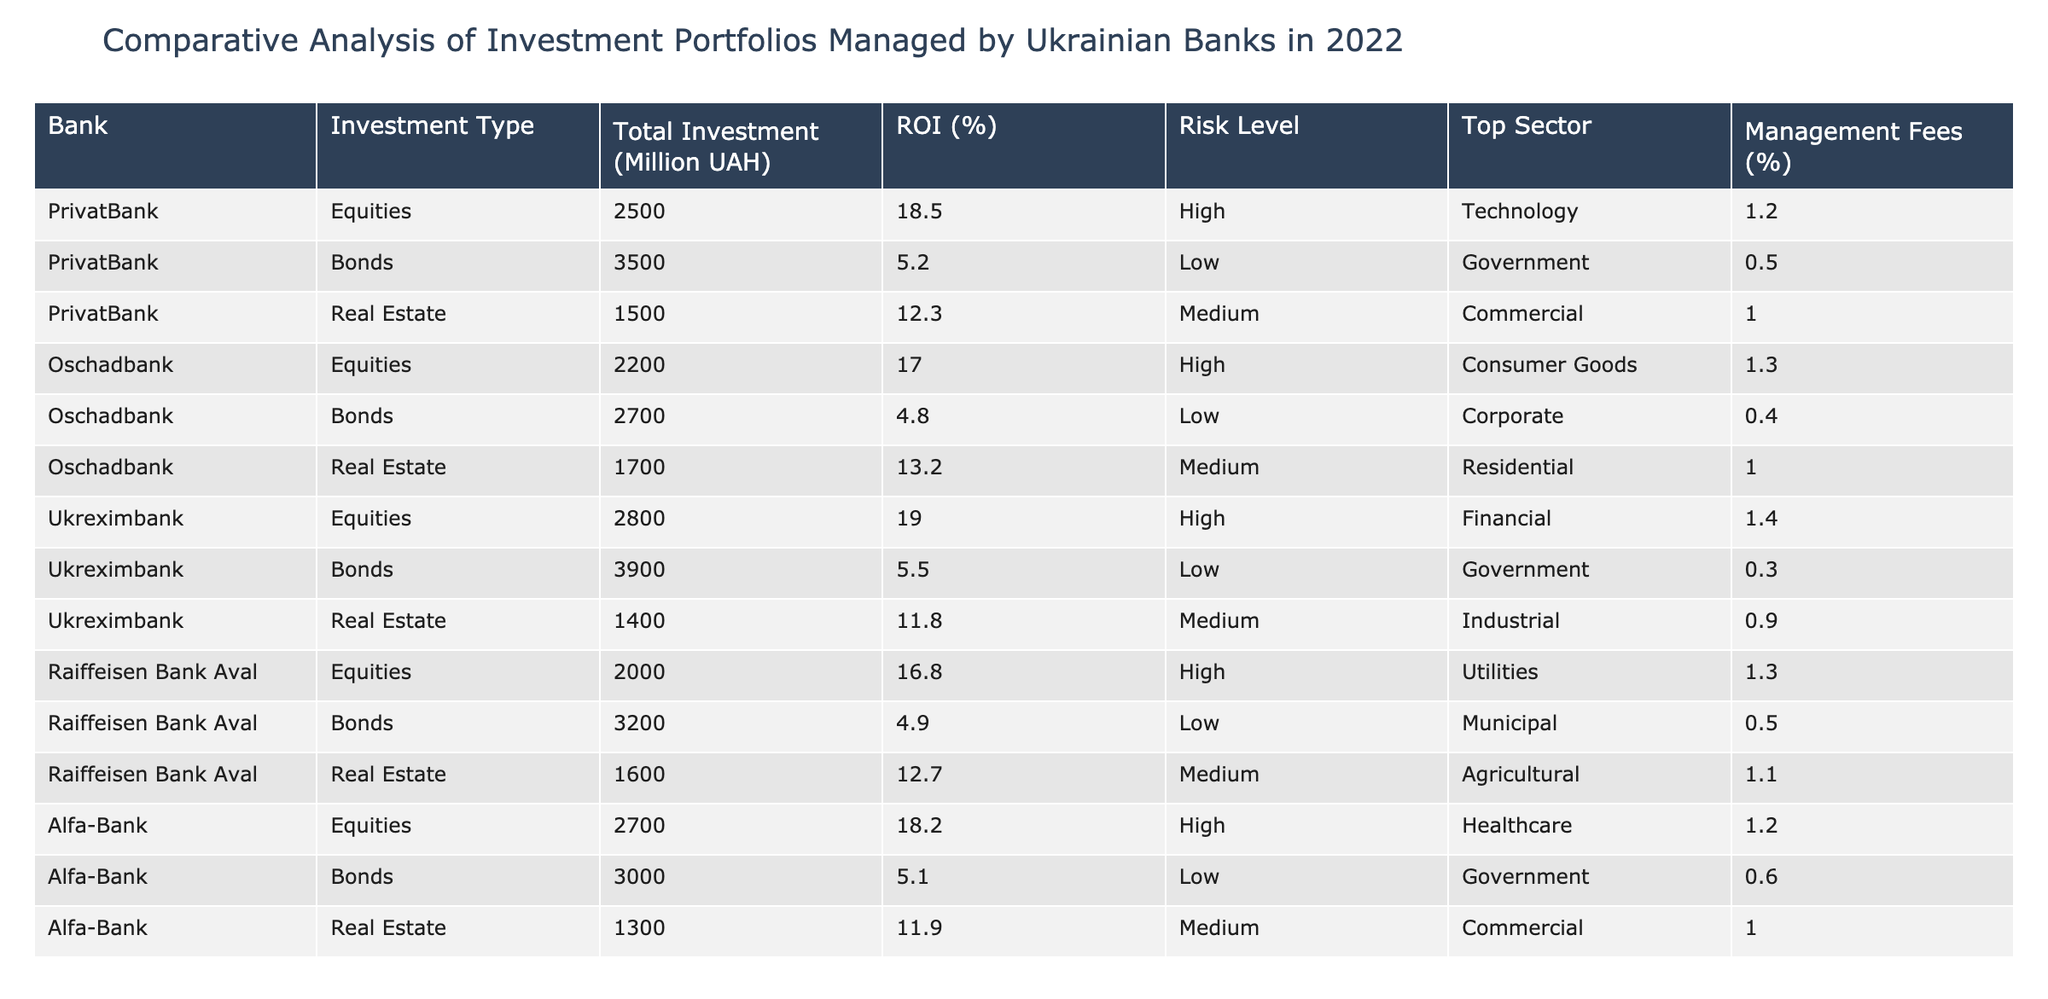What is the total investment by PrivatBank in bonds? According to the table, PrivatBank has a total investment of 3500 million UAH in bonds.
Answer: 3500 million UAH Which bank has invested the most in equities? From the table, Ukreximbank has the highest investment in equities with 2800 million UAH.
Answer: Ukreximbank What is the average ROI for the real estate investments across all banks? The real estate investments and their ROI are: PrivatBank (12.3%), Oschadbank (13.2%), Ukreximbank (11.8%), Raiffeisen Bank Aval (12.7%), Alfa-Bank (11.9%). The sum of these ROIs is 12.3 + 13.2 + 11.8 + 12.7 + 11.9 = 61.9%. There are 5 data points, so the average ROI is 61.9/5 = 12.38%.
Answer: 12.38% Does any bank have a risk level categorized as low for equities? Upon reviewing the table, all banks have categorized equities investment with a risk level of High. Therefore, none of the banks have a low risk level for equities.
Answer: No What is the difference in total investments between Ukreximbank and Oschadbank across all types? Ukreximbank's total investments are: Equities (2800) + Bonds (3900) + Real Estate (1400) = 8100 million UAH. Oschadbank's total investments are: Equities (2200) + Bonds (2700) + Real Estate (1700) = 6600 million UAH. The difference is 8100 - 6600 = 1500 million UAH.
Answer: 1500 million UAH Which sector has the highest total investment for Alfa-Bank? For Alfa-Bank, investments are: Equities (2700 million UAH in Healthcare), Bonds (3000 million UAH in Government), and Real Estate (1300 million UAH in Commercial). The highest investment is in Bonds with 3000 million UAH in the Government sector.
Answer: Government Is the management fee for bonds higher than for equities for any of the banks? Looking at the management fees: PrivatBank (Bonds: 0.5%, Equities: 1.2%), Oschadbank (Bonds: 0.4%, Equities: 1.3%), Ukreximbank (Bonds: 0.3%, Equities: 1.4%), Raiffeisen Bank Aval (Bonds: 0.5%, Equities: 1.3%), and Alfa-Bank (Bonds: 0.6%, Equities: 1.2%). In all cases, the management fee for equities is higher than for bonds.
Answer: No What is the total ROI for all bonds managed by the banks? The total ROI for bonds from all banks is calculated as follows: PrivatBank at 5.2%, Oschadbank at 4.8%, Ukreximbank at 5.5%, Raiffeisen Bank Aval at 4.9%, and Alfa-Bank at 5.1%. The total ROI is 5.2 + 4.8 + 5.5 + 4.9 + 5.1 = 25.5%. Therefore, across all bonds, the total ROI is 25.5%.
Answer: 25.5% 